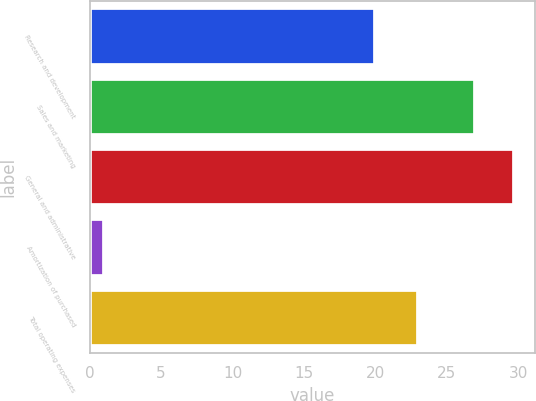<chart> <loc_0><loc_0><loc_500><loc_500><bar_chart><fcel>Research and development<fcel>Sales and marketing<fcel>General and administrative<fcel>Amortization of purchased<fcel>Total operating expenses<nl><fcel>20<fcel>27<fcel>29.7<fcel>1<fcel>23<nl></chart> 